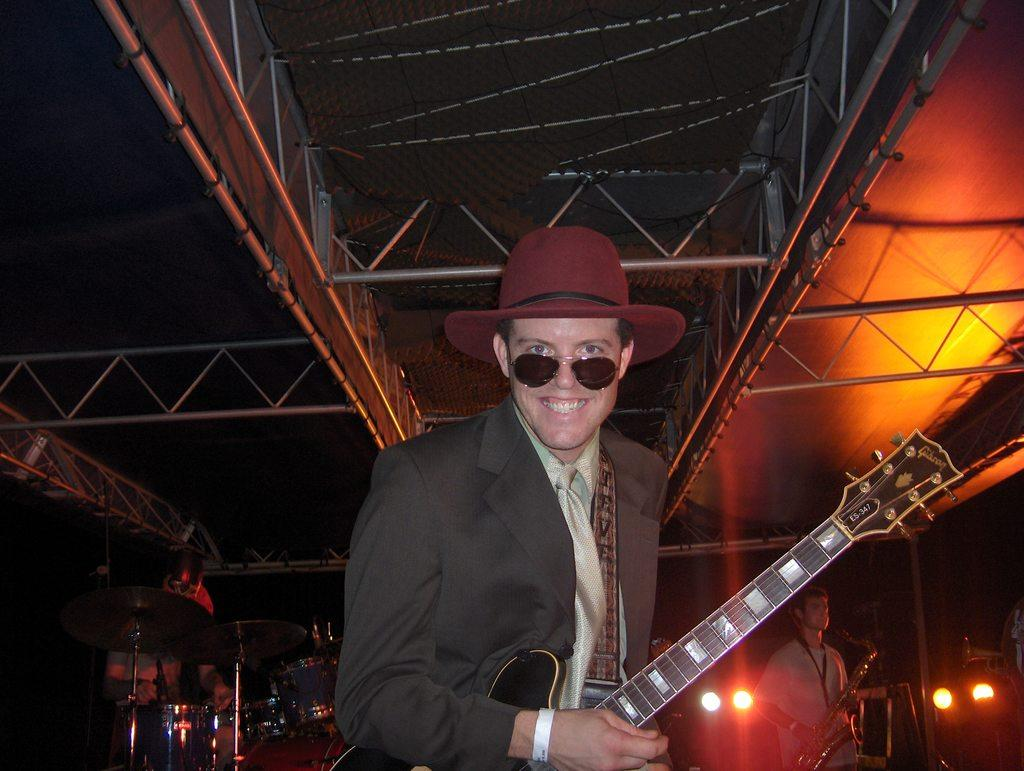What is the man in the image doing? The man is standing and holding a guitar. What is the man's facial expression in the image? The man is smiling in the image. What is the man wearing on his head? The man is wearing a hat in the image. Who else is present in the image? There is another person in the image. What is the other person doing? The other person is standing and holding a saxophone. What musical instrument can be seen in the image? There is a drum set in the image. What is the governor doing in the image? There is no governor present in the image. What type of spring can be seen in the image? There is no spring present in the image. 